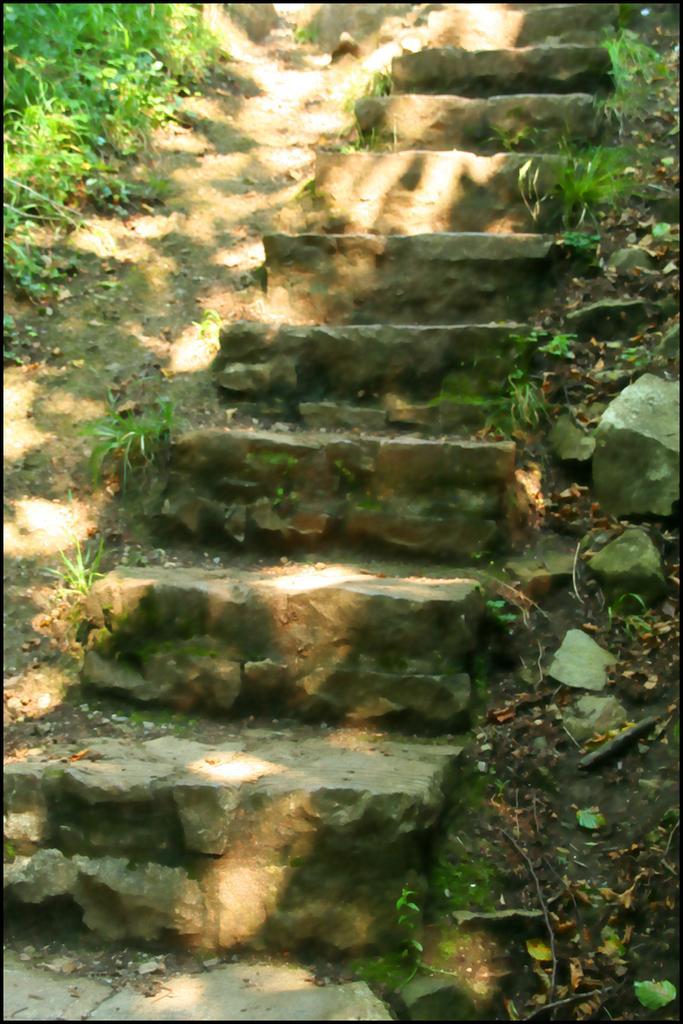Describe this image in one or two sentences. In the picture there are steps made up stones and around those steps there is some grass. 